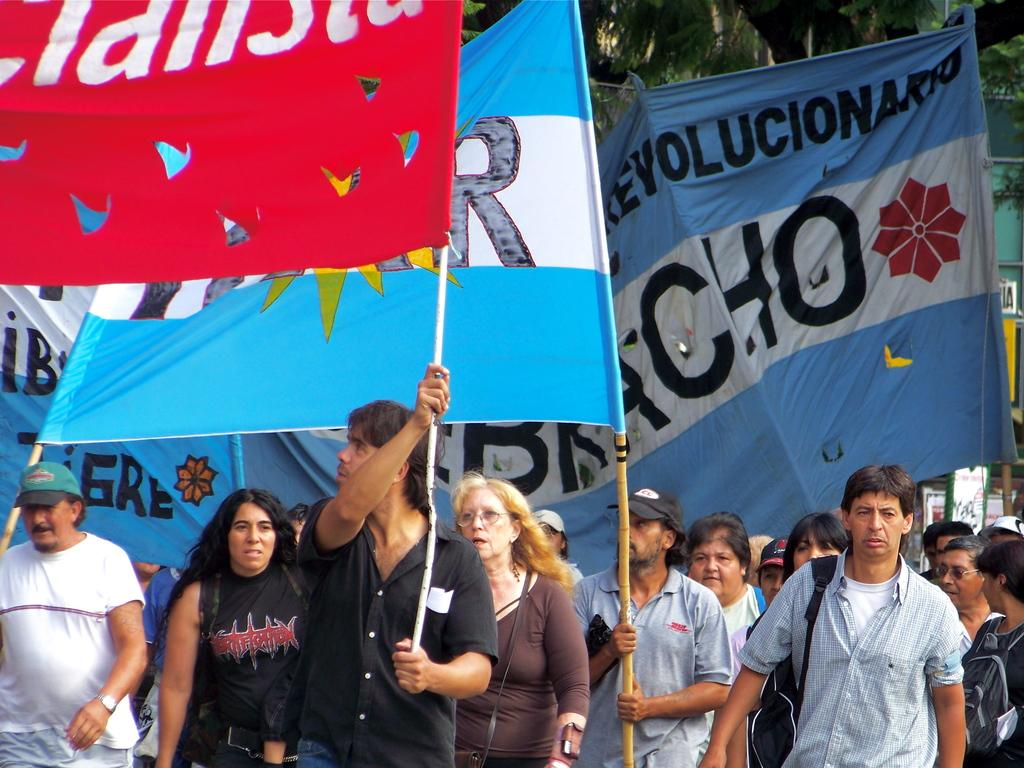Provide a one-sentence caption for the provided image. Protesters march holding Spanish language banners with "revolutionary" messages. 